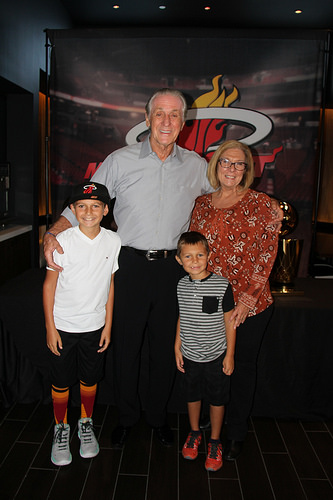<image>
Is there a boy under the shoe? No. The boy is not positioned under the shoe. The vertical relationship between these objects is different. 